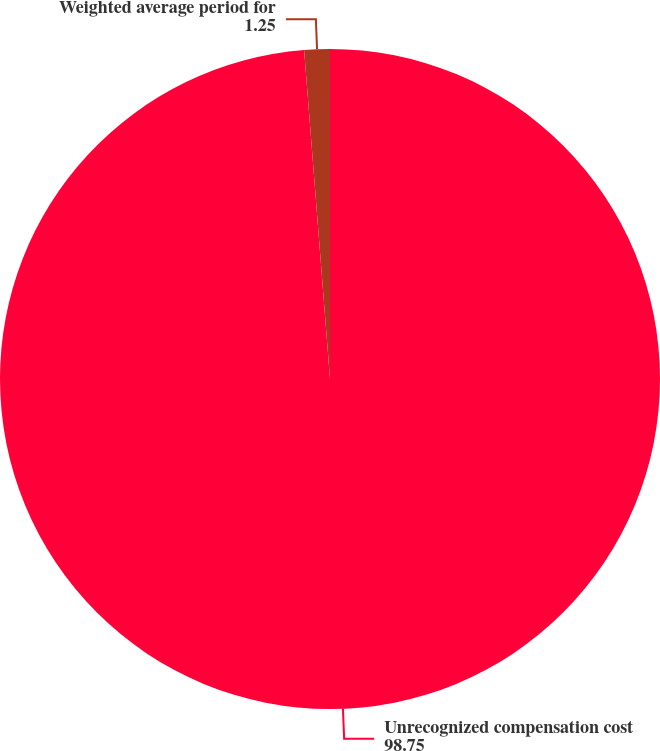Convert chart to OTSL. <chart><loc_0><loc_0><loc_500><loc_500><pie_chart><fcel>Unrecognized compensation cost<fcel>Weighted average period for<nl><fcel>98.75%<fcel>1.25%<nl></chart> 